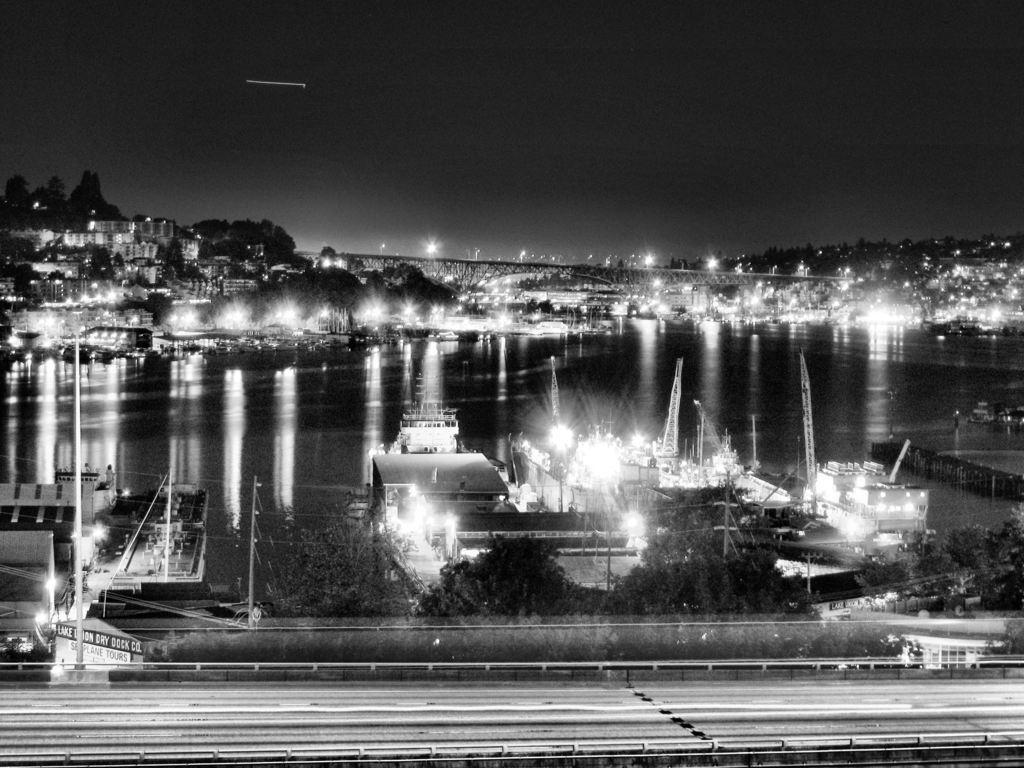How would you summarize this image in a sentence or two? This image is taken during night time. There are buildings with lightning. There are also poles with wires. Trees, boats are also visible. There is also bridge and road. At the top there is sky. River is also present. 